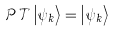Convert formula to latex. <formula><loc_0><loc_0><loc_500><loc_500>\mathcal { P T } \left | \psi _ { k } \right \rangle = \left | \psi _ { k } \right \rangle</formula> 